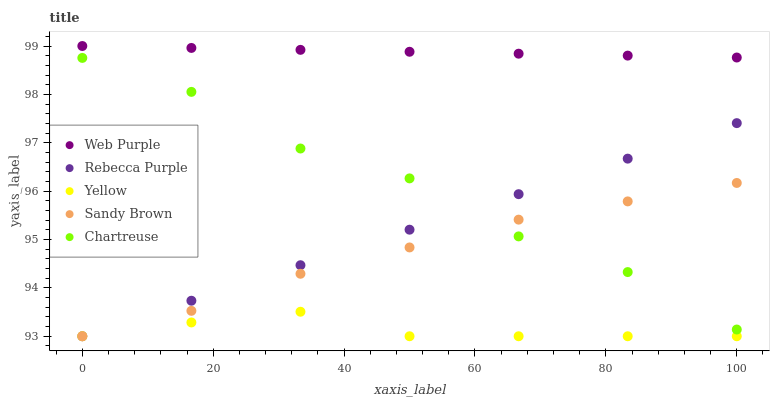Does Yellow have the minimum area under the curve?
Answer yes or no. Yes. Does Web Purple have the maximum area under the curve?
Answer yes or no. Yes. Does Sandy Brown have the minimum area under the curve?
Answer yes or no. No. Does Sandy Brown have the maximum area under the curve?
Answer yes or no. No. Is Web Purple the smoothest?
Answer yes or no. Yes. Is Chartreuse the roughest?
Answer yes or no. Yes. Is Sandy Brown the smoothest?
Answer yes or no. No. Is Sandy Brown the roughest?
Answer yes or no. No. Does Sandy Brown have the lowest value?
Answer yes or no. Yes. Does Web Purple have the lowest value?
Answer yes or no. No. Does Web Purple have the highest value?
Answer yes or no. Yes. Does Sandy Brown have the highest value?
Answer yes or no. No. Is Chartreuse less than Web Purple?
Answer yes or no. Yes. Is Web Purple greater than Rebecca Purple?
Answer yes or no. Yes. Does Rebecca Purple intersect Sandy Brown?
Answer yes or no. Yes. Is Rebecca Purple less than Sandy Brown?
Answer yes or no. No. Is Rebecca Purple greater than Sandy Brown?
Answer yes or no. No. Does Chartreuse intersect Web Purple?
Answer yes or no. No. 